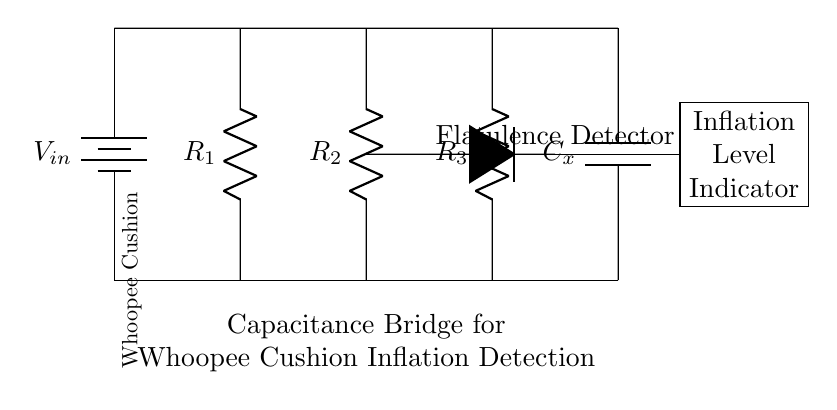What type of circuit is shown? The circuit is a capacitance bridge, designed to compare capacitance values.
Answer: capacitance bridge What is the role of the component labeled C_x? C_x is the capacitor representing the whoopee cushion, which changes capacitance based on inflation.
Answer: whoopee cushion What does the label "Flatulence Detector" refer to? The "Flatulence Detector" identifies the changes in capacitance caused by inflation in the whoopee cushion.
Answer: detects inflation How many resistors are in the circuit? There are three resistors (R1, R2, R3) in the circuit.
Answer: three What is the purpose of the inflation level indicator? The inflation level indicator shows the levels of inflation detected by the circuit, translating capacitance changes into a visual output.
Answer: shows inflation level What is the input source of voltage in the circuit? The input voltage for the circuit is provided by the battery labeled V_in, which powers the circuit.
Answer: V_in What should happen to the capacitor as the whoopee cushion inflates? As the cushion inflates, the capacitance C_x increases, which affects the balance of the bridge circuit.
Answer: capacitance increases 